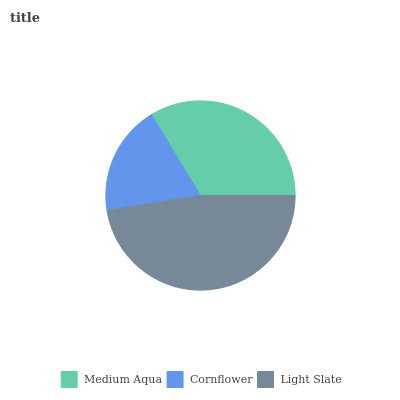Is Cornflower the minimum?
Answer yes or no. Yes. Is Light Slate the maximum?
Answer yes or no. Yes. Is Light Slate the minimum?
Answer yes or no. No. Is Cornflower the maximum?
Answer yes or no. No. Is Light Slate greater than Cornflower?
Answer yes or no. Yes. Is Cornflower less than Light Slate?
Answer yes or no. Yes. Is Cornflower greater than Light Slate?
Answer yes or no. No. Is Light Slate less than Cornflower?
Answer yes or no. No. Is Medium Aqua the high median?
Answer yes or no. Yes. Is Medium Aqua the low median?
Answer yes or no. Yes. Is Cornflower the high median?
Answer yes or no. No. Is Cornflower the low median?
Answer yes or no. No. 